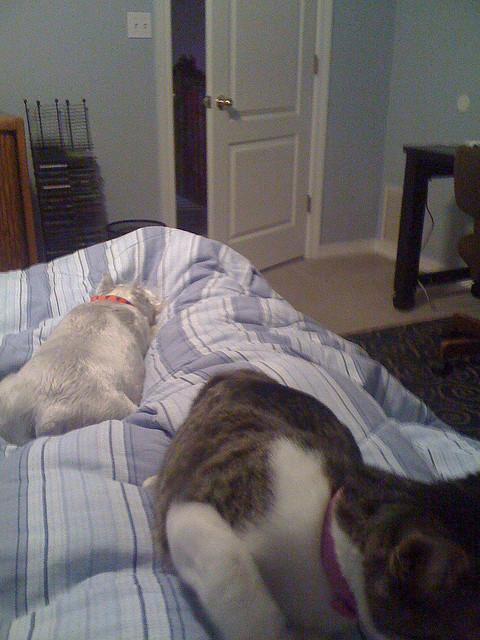How many cats are on the bed?
Give a very brief answer. 2. How many different animals are in the room?
Give a very brief answer. 2. How many beds do the cats have?
Give a very brief answer. 1. How many cats are there?
Give a very brief answer. 2. 